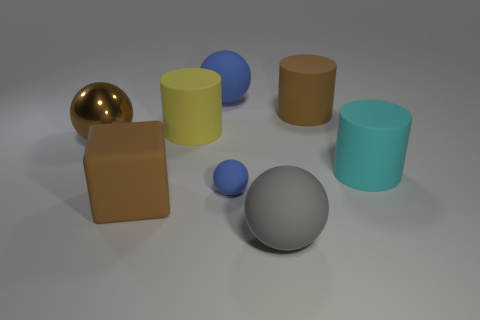Add 1 big cyan cylinders. How many objects exist? 9 Subtract all cylinders. How many objects are left? 5 Subtract 1 gray balls. How many objects are left? 7 Subtract all tiny blue things. Subtract all brown rubber things. How many objects are left? 5 Add 8 big gray matte things. How many big gray matte things are left? 9 Add 2 big brown matte cubes. How many big brown matte cubes exist? 3 